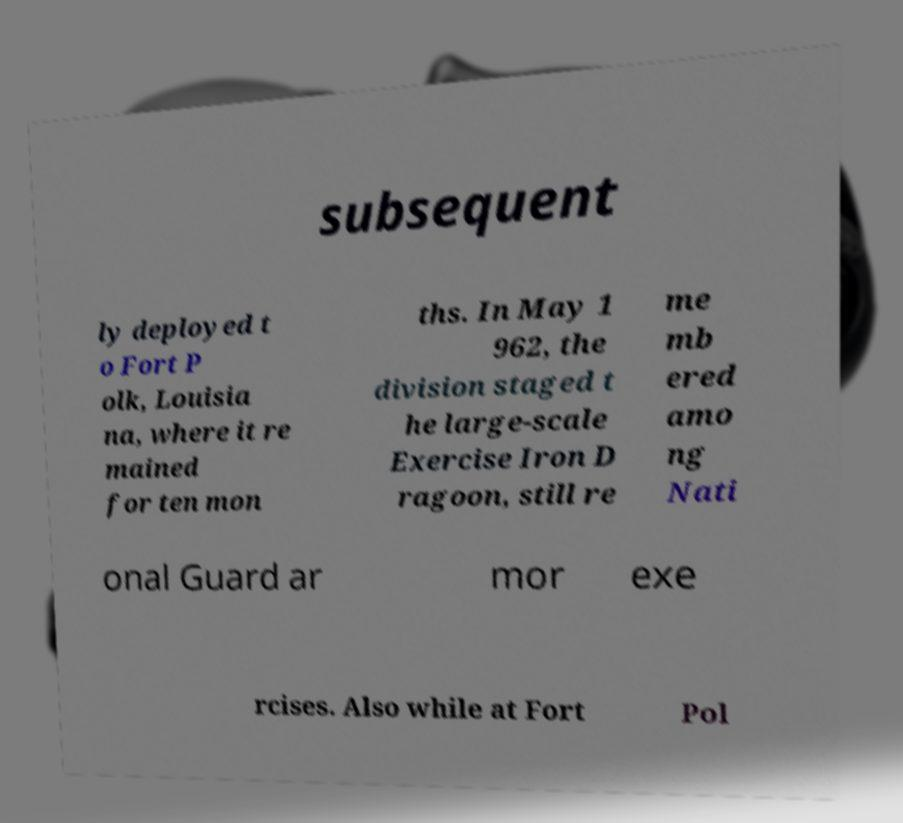Please identify and transcribe the text found in this image. subsequent ly deployed t o Fort P olk, Louisia na, where it re mained for ten mon ths. In May 1 962, the division staged t he large-scale Exercise Iron D ragoon, still re me mb ered amo ng Nati onal Guard ar mor exe rcises. Also while at Fort Pol 